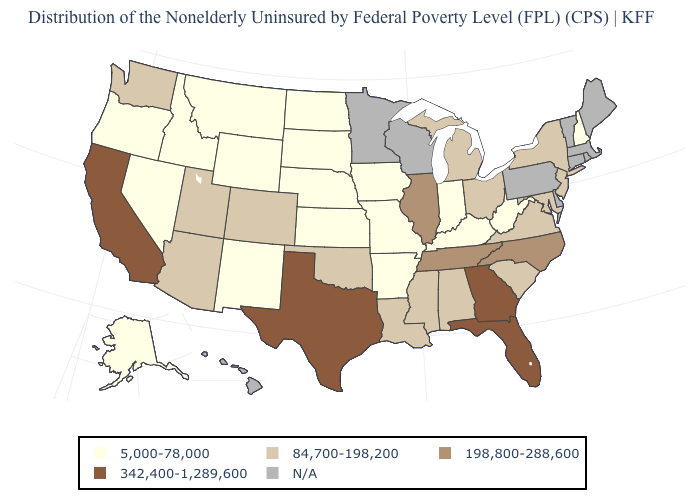Does West Virginia have the highest value in the USA?
Concise answer only. No. Is the legend a continuous bar?
Keep it brief. No. What is the value of Maryland?
Keep it brief. 84,700-198,200. What is the value of South Dakota?
Concise answer only. 5,000-78,000. Which states have the lowest value in the South?
Short answer required. Arkansas, Kentucky, West Virginia. Name the states that have a value in the range 342,400-1,289,600?
Write a very short answer. California, Florida, Georgia, Texas. Which states hav the highest value in the Northeast?
Write a very short answer. New Jersey, New York. Does Montana have the lowest value in the USA?
Keep it brief. Yes. What is the highest value in states that border Florida?
Short answer required. 342,400-1,289,600. Among the states that border Indiana , which have the highest value?
Keep it brief. Illinois. What is the value of North Dakota?
Answer briefly. 5,000-78,000. Name the states that have a value in the range N/A?
Be succinct. Connecticut, Delaware, Hawaii, Maine, Massachusetts, Minnesota, Pennsylvania, Rhode Island, Vermont, Wisconsin. Name the states that have a value in the range 342,400-1,289,600?
Answer briefly. California, Florida, Georgia, Texas. 